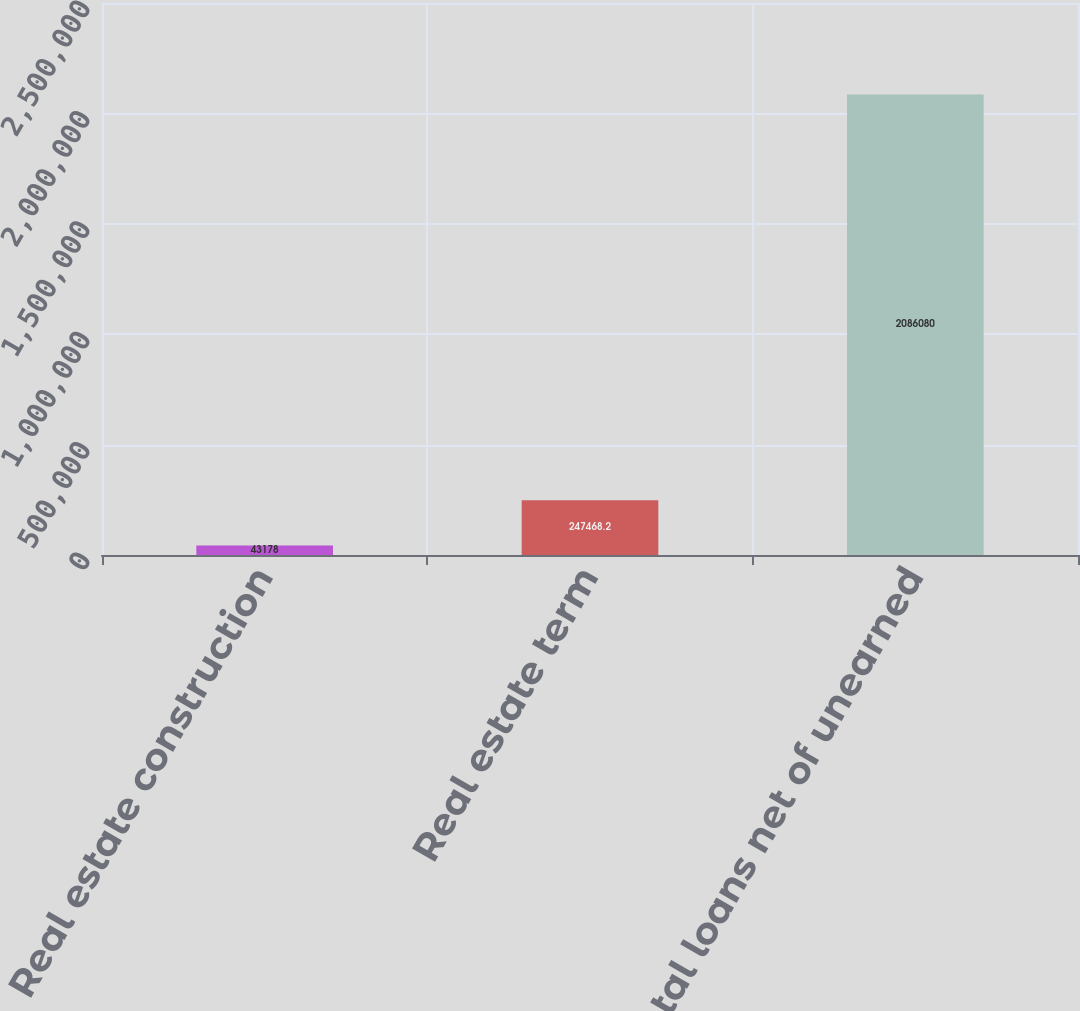<chart> <loc_0><loc_0><loc_500><loc_500><bar_chart><fcel>Real estate construction<fcel>Real estate term<fcel>Total loans net of unearned<nl><fcel>43178<fcel>247468<fcel>2.08608e+06<nl></chart> 